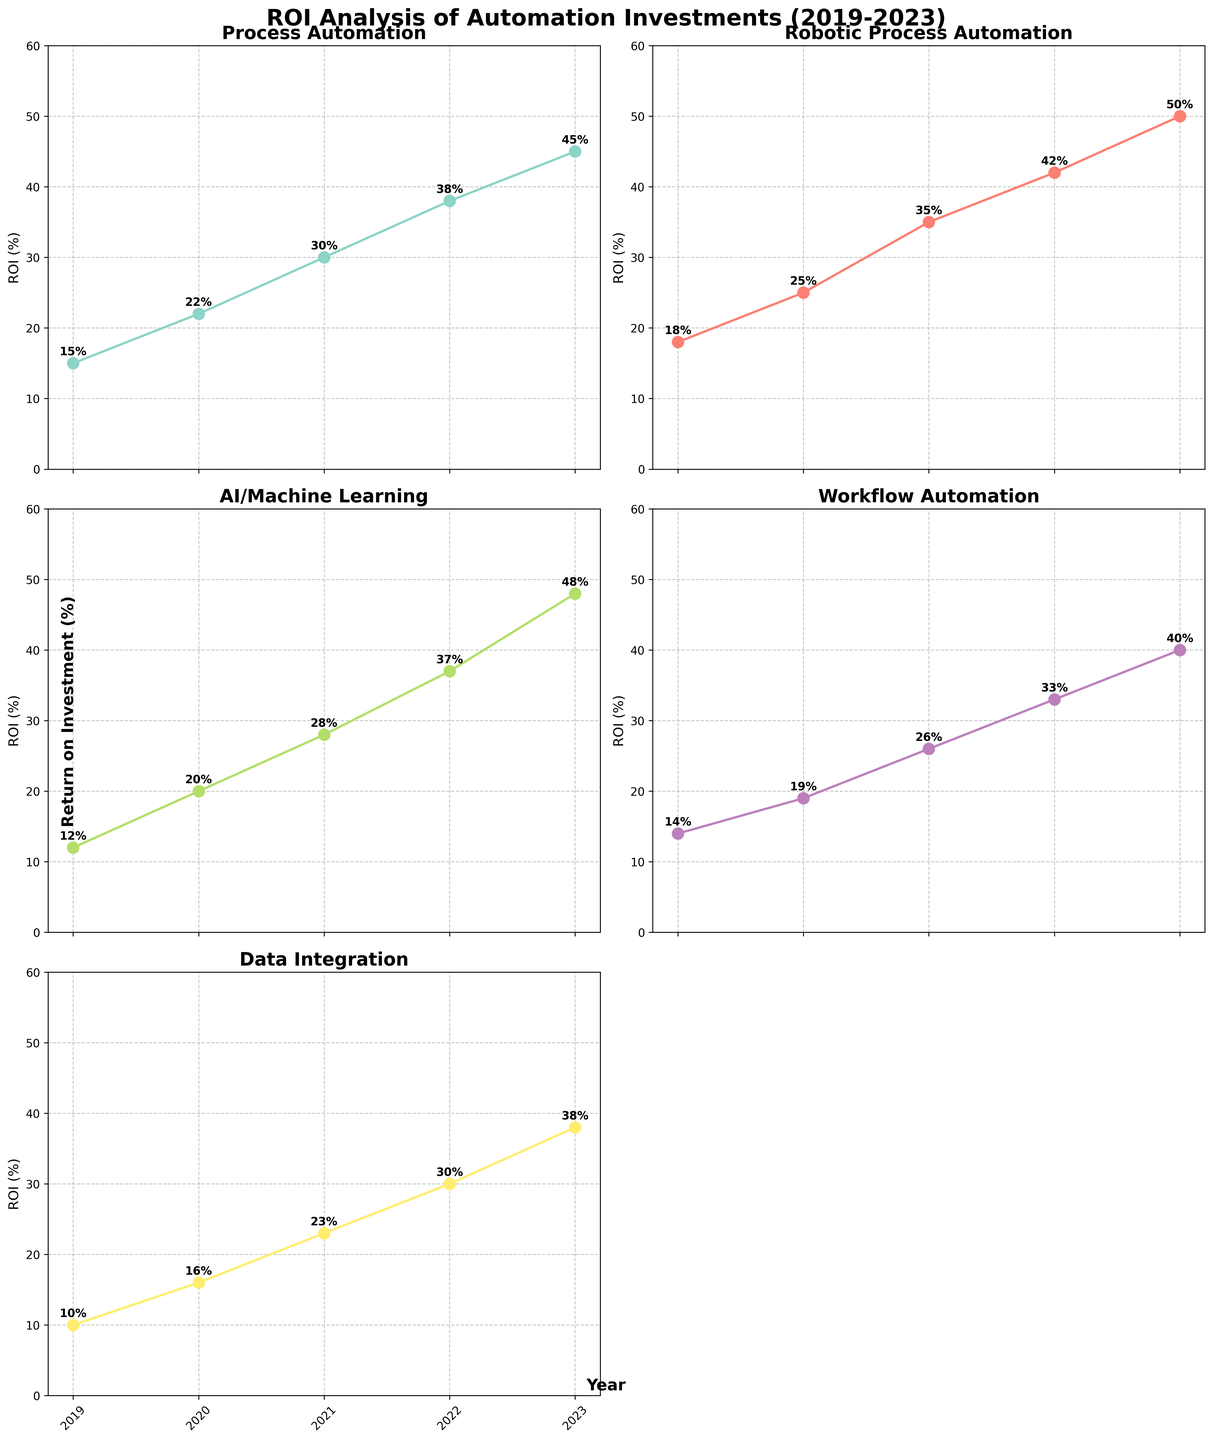Which project type had the highest ROI in 2021? To answer this, look at the subplots for each project type and find the ROI percentage for the year 2021. The highest one belongs to the project marked "2021" in the subplots. The ROI for each project type in 2021 are: Process Automation - 30%, Robotic Process Automation - 35%, AI/Machine Learning - 28%, Workflow Automation - 26%, and Data Integration - 23%. Robotic Process Automation has the highest ROI.
Answer: Robotic Process Automation What’s the difference in ROI between Process Automation and Workflow Automation in 2023? Observe the subplots for both Process Automation and Workflow Automation for the year 2023. Process Automation has an ROI of 45% and Workflow Automation has an ROI of 40%. The difference is 45% - 40% which equals 5%.
Answer: 5% Which year did AI/Machine Learning see the biggest increase in ROI compared to the previous year? To find this, calculate the year-on-year differences in ROI for AI/Machine Learning. From 2019 to 2020, it increased by 8% (20% - 12%). From 2020 to 2021, it increased by 8% (28% - 20%). From 2021 to 2022, it increased by 9% (37% - 28%). From 2022 to 2023, it increased by 11% (48% - 37%). So, the biggest increase is from 2022 to 2023.
Answer: 2022 to 2023 On which project type does the ROI grow most consistently over the years? Look at each subplot and examine the trend lines for consistency. The project types with steady growth each year are Process Automation, Robotic Process Automation, AI/Machine Learning, Workflow Automation, and Data Integration. The one with the most uniform upward trend is Robotic Process Automation, showing a consistent steady increase each year.
Answer: Robotic Process Automation Which project type saw the smallest overall increase in ROI from 2019 to 2023? Calculate the increase in ROI for each project type from 2019 to 2023. Process Automation increases from 15% to 45%, a 30% increase. Robotic Process Automation increases from 18% to 50%, a 32% increase. AI/Machine Learning increases from 12% to 48%, a 36% increase. Workflow Automation increases from 14% to 40%, a 26% increase. Data Integration increases from 10% to 38%, a 28% increase. Workflow Automation has the smallest overall increase.
Answer: Workflow Automation Which project type had the lowest ROI in 2020? Check each subplot for the ROI values in 2020. Process Automation had 22%, Robotic Process Automation had 25%, AI/Machine Learning had 20%, Workflow Automation had 19%, and Data Integration had 16%. Data Integration has the lowest ROI.
Answer: Data Integration Can you find the average ROI for Workflow Automation from 2019 to 2023? To find the average, add up the ROI values for Workflow Automation for each year and divide by the number of years: (14% + 19% + 26% + 33% + 40%) / 5 = 132% / 5 = 26.4%.
Answer: 26.4% What is the difference in the highest and lowest ROI values for Data Integration over the 5-year period? Locate the subplots for Data Integration and find the highest and lowest ROI values. The highest is 38% in 2023 and the lowest is 10% in 2019. The difference is 38% - 10% = 28%.
Answer: 28% Which two project types showed the closest ROI values in 2022? Compare the ROI values for each project type in 2022. The values are: Process Automation - 38%, Robotic Process Automation - 42%, AI/Machine Learning - 37%, Workflow Automation - 33%, and Data Integration - 30%. Process Automation and AI/Machine Learning have the closest values, 38% and 37% respectively.
Answer: Process Automation and AI/Machine Learning 